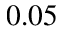<formula> <loc_0><loc_0><loc_500><loc_500>0 . 0 5</formula> 